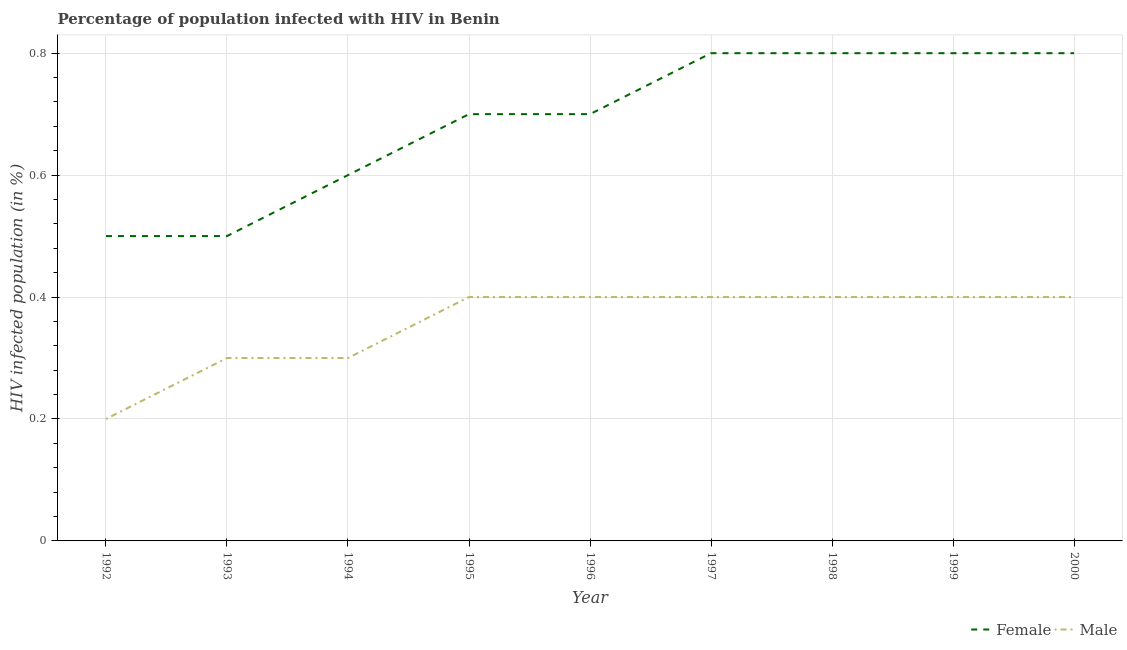Does the line corresponding to percentage of males who are infected with hiv intersect with the line corresponding to percentage of females who are infected with hiv?
Give a very brief answer. No. Is the number of lines equal to the number of legend labels?
Give a very brief answer. Yes. Across all years, what is the minimum percentage of females who are infected with hiv?
Your answer should be compact. 0.5. In which year was the percentage of males who are infected with hiv maximum?
Your answer should be compact. 1995. In which year was the percentage of females who are infected with hiv minimum?
Keep it short and to the point. 1992. What is the total percentage of females who are infected with hiv in the graph?
Your response must be concise. 6.2. What is the difference between the percentage of females who are infected with hiv in 1996 and that in 2000?
Your answer should be very brief. -0.1. What is the difference between the percentage of females who are infected with hiv in 1998 and the percentage of males who are infected with hiv in 2000?
Make the answer very short. 0.4. What is the average percentage of females who are infected with hiv per year?
Ensure brevity in your answer.  0.69. In how many years, is the percentage of males who are infected with hiv greater than 0.6400000000000001 %?
Your response must be concise. 0. What is the ratio of the percentage of females who are infected with hiv in 1993 to that in 1994?
Make the answer very short. 0.83. Is the percentage of females who are infected with hiv in 1997 less than that in 1998?
Give a very brief answer. No. What is the difference between the highest and the second highest percentage of females who are infected with hiv?
Provide a succinct answer. 0. What is the difference between the highest and the lowest percentage of females who are infected with hiv?
Your response must be concise. 0.3. Is the sum of the percentage of males who are infected with hiv in 1992 and 1994 greater than the maximum percentage of females who are infected with hiv across all years?
Your answer should be compact. No. Does the percentage of females who are infected with hiv monotonically increase over the years?
Offer a terse response. No. Is the percentage of females who are infected with hiv strictly less than the percentage of males who are infected with hiv over the years?
Offer a very short reply. No. How many years are there in the graph?
Offer a very short reply. 9. What is the difference between two consecutive major ticks on the Y-axis?
Make the answer very short. 0.2. Does the graph contain grids?
Your answer should be very brief. Yes. Where does the legend appear in the graph?
Your answer should be compact. Bottom right. How are the legend labels stacked?
Keep it short and to the point. Horizontal. What is the title of the graph?
Provide a short and direct response. Percentage of population infected with HIV in Benin. What is the label or title of the Y-axis?
Your answer should be compact. HIV infected population (in %). What is the HIV infected population (in %) in Male in 1992?
Your answer should be very brief. 0.2. What is the HIV infected population (in %) in Female in 1993?
Your answer should be very brief. 0.5. What is the HIV infected population (in %) of Male in 1993?
Keep it short and to the point. 0.3. What is the HIV infected population (in %) of Male in 1994?
Make the answer very short. 0.3. What is the HIV infected population (in %) in Female in 1996?
Keep it short and to the point. 0.7. What is the HIV infected population (in %) of Male in 1996?
Your response must be concise. 0.4. What is the HIV infected population (in %) of Male in 1997?
Provide a succinct answer. 0.4. What is the HIV infected population (in %) in Female in 1998?
Keep it short and to the point. 0.8. What is the HIV infected population (in %) in Male in 1998?
Your answer should be very brief. 0.4. What is the HIV infected population (in %) in Female in 1999?
Provide a succinct answer. 0.8. What is the HIV infected population (in %) of Female in 2000?
Your answer should be very brief. 0.8. Across all years, what is the maximum HIV infected population (in %) of Male?
Provide a short and direct response. 0.4. What is the total HIV infected population (in %) of Male in the graph?
Your answer should be compact. 3.2. What is the difference between the HIV infected population (in %) in Female in 1992 and that in 1993?
Your answer should be very brief. 0. What is the difference between the HIV infected population (in %) of Female in 1992 and that in 1994?
Provide a short and direct response. -0.1. What is the difference between the HIV infected population (in %) in Male in 1992 and that in 1994?
Offer a terse response. -0.1. What is the difference between the HIV infected population (in %) of Male in 1992 and that in 1995?
Offer a very short reply. -0.2. What is the difference between the HIV infected population (in %) of Female in 1992 and that in 1996?
Your answer should be very brief. -0.2. What is the difference between the HIV infected population (in %) in Female in 1992 and that in 1997?
Give a very brief answer. -0.3. What is the difference between the HIV infected population (in %) in Male in 1992 and that in 1997?
Ensure brevity in your answer.  -0.2. What is the difference between the HIV infected population (in %) in Female in 1992 and that in 1998?
Your response must be concise. -0.3. What is the difference between the HIV infected population (in %) of Female in 1992 and that in 1999?
Keep it short and to the point. -0.3. What is the difference between the HIV infected population (in %) of Male in 1992 and that in 1999?
Provide a short and direct response. -0.2. What is the difference between the HIV infected population (in %) of Male in 1992 and that in 2000?
Give a very brief answer. -0.2. What is the difference between the HIV infected population (in %) in Male in 1993 and that in 1994?
Provide a short and direct response. 0. What is the difference between the HIV infected population (in %) in Female in 1993 and that in 1995?
Give a very brief answer. -0.2. What is the difference between the HIV infected population (in %) of Male in 1993 and that in 1996?
Provide a short and direct response. -0.1. What is the difference between the HIV infected population (in %) in Female in 1993 and that in 1998?
Keep it short and to the point. -0.3. What is the difference between the HIV infected population (in %) of Male in 1993 and that in 1998?
Your response must be concise. -0.1. What is the difference between the HIV infected population (in %) in Female in 1993 and that in 2000?
Your response must be concise. -0.3. What is the difference between the HIV infected population (in %) in Male in 1993 and that in 2000?
Ensure brevity in your answer.  -0.1. What is the difference between the HIV infected population (in %) in Male in 1994 and that in 1995?
Offer a very short reply. -0.1. What is the difference between the HIV infected population (in %) of Female in 1994 and that in 1996?
Offer a terse response. -0.1. What is the difference between the HIV infected population (in %) of Female in 1994 and that in 1997?
Your response must be concise. -0.2. What is the difference between the HIV infected population (in %) of Female in 1994 and that in 1999?
Offer a very short reply. -0.2. What is the difference between the HIV infected population (in %) of Female in 1994 and that in 2000?
Ensure brevity in your answer.  -0.2. What is the difference between the HIV infected population (in %) of Female in 1995 and that in 1996?
Keep it short and to the point. 0. What is the difference between the HIV infected population (in %) of Female in 1995 and that in 1998?
Give a very brief answer. -0.1. What is the difference between the HIV infected population (in %) of Female in 1995 and that in 2000?
Your answer should be very brief. -0.1. What is the difference between the HIV infected population (in %) of Male in 1995 and that in 2000?
Give a very brief answer. 0. What is the difference between the HIV infected population (in %) of Female in 1996 and that in 1998?
Give a very brief answer. -0.1. What is the difference between the HIV infected population (in %) of Male in 1996 and that in 1998?
Give a very brief answer. 0. What is the difference between the HIV infected population (in %) of Male in 1996 and that in 1999?
Give a very brief answer. 0. What is the difference between the HIV infected population (in %) in Female in 1997 and that in 1998?
Ensure brevity in your answer.  0. What is the difference between the HIV infected population (in %) in Female in 1997 and that in 1999?
Offer a terse response. 0. What is the difference between the HIV infected population (in %) in Male in 1997 and that in 1999?
Offer a very short reply. 0. What is the difference between the HIV infected population (in %) of Female in 1997 and that in 2000?
Make the answer very short. 0. What is the difference between the HIV infected population (in %) of Male in 1997 and that in 2000?
Keep it short and to the point. 0. What is the difference between the HIV infected population (in %) in Female in 1998 and that in 1999?
Your response must be concise. 0. What is the difference between the HIV infected population (in %) in Male in 1998 and that in 1999?
Your response must be concise. 0. What is the difference between the HIV infected population (in %) of Female in 1999 and that in 2000?
Your answer should be very brief. 0. What is the difference between the HIV infected population (in %) in Female in 1992 and the HIV infected population (in %) in Male in 1995?
Your answer should be very brief. 0.1. What is the difference between the HIV infected population (in %) in Female in 1992 and the HIV infected population (in %) in Male in 1997?
Ensure brevity in your answer.  0.1. What is the difference between the HIV infected population (in %) in Female in 1992 and the HIV infected population (in %) in Male in 2000?
Keep it short and to the point. 0.1. What is the difference between the HIV infected population (in %) in Female in 1993 and the HIV infected population (in %) in Male in 1998?
Make the answer very short. 0.1. What is the difference between the HIV infected population (in %) of Female in 1993 and the HIV infected population (in %) of Male in 1999?
Offer a terse response. 0.1. What is the difference between the HIV infected population (in %) of Female in 1993 and the HIV infected population (in %) of Male in 2000?
Provide a succinct answer. 0.1. What is the difference between the HIV infected population (in %) of Female in 1994 and the HIV infected population (in %) of Male in 1995?
Give a very brief answer. 0.2. What is the difference between the HIV infected population (in %) of Female in 1994 and the HIV infected population (in %) of Male in 1996?
Your answer should be very brief. 0.2. What is the difference between the HIV infected population (in %) of Female in 1994 and the HIV infected population (in %) of Male in 1997?
Your answer should be very brief. 0.2. What is the difference between the HIV infected population (in %) in Female in 1994 and the HIV infected population (in %) in Male in 1998?
Give a very brief answer. 0.2. What is the difference between the HIV infected population (in %) in Female in 1995 and the HIV infected population (in %) in Male in 1997?
Provide a short and direct response. 0.3. What is the difference between the HIV infected population (in %) in Female in 1996 and the HIV infected population (in %) in Male in 1998?
Provide a short and direct response. 0.3. What is the difference between the HIV infected population (in %) in Female in 1996 and the HIV infected population (in %) in Male in 1999?
Provide a short and direct response. 0.3. What is the difference between the HIV infected population (in %) in Female in 1997 and the HIV infected population (in %) in Male in 1999?
Provide a succinct answer. 0.4. What is the difference between the HIV infected population (in %) in Female in 1998 and the HIV infected population (in %) in Male in 1999?
Give a very brief answer. 0.4. What is the difference between the HIV infected population (in %) in Female in 1999 and the HIV infected population (in %) in Male in 2000?
Your response must be concise. 0.4. What is the average HIV infected population (in %) of Female per year?
Your answer should be very brief. 0.69. What is the average HIV infected population (in %) of Male per year?
Your response must be concise. 0.36. In the year 1995, what is the difference between the HIV infected population (in %) of Female and HIV infected population (in %) of Male?
Your answer should be very brief. 0.3. In the year 1999, what is the difference between the HIV infected population (in %) of Female and HIV infected population (in %) of Male?
Offer a terse response. 0.4. In the year 2000, what is the difference between the HIV infected population (in %) of Female and HIV infected population (in %) of Male?
Make the answer very short. 0.4. What is the ratio of the HIV infected population (in %) in Female in 1992 to that in 1993?
Your answer should be compact. 1. What is the ratio of the HIV infected population (in %) in Male in 1992 to that in 1993?
Offer a very short reply. 0.67. What is the ratio of the HIV infected population (in %) in Female in 1992 to that in 1994?
Your answer should be very brief. 0.83. What is the ratio of the HIV infected population (in %) of Male in 1992 to that in 1994?
Offer a terse response. 0.67. What is the ratio of the HIV infected population (in %) in Female in 1992 to that in 1998?
Give a very brief answer. 0.62. What is the ratio of the HIV infected population (in %) of Male in 1992 to that in 1998?
Your response must be concise. 0.5. What is the ratio of the HIV infected population (in %) of Female in 1992 to that in 1999?
Keep it short and to the point. 0.62. What is the ratio of the HIV infected population (in %) of Female in 1992 to that in 2000?
Ensure brevity in your answer.  0.62. What is the ratio of the HIV infected population (in %) of Male in 1992 to that in 2000?
Provide a short and direct response. 0.5. What is the ratio of the HIV infected population (in %) of Male in 1993 to that in 1994?
Provide a short and direct response. 1. What is the ratio of the HIV infected population (in %) in Female in 1993 to that in 1995?
Offer a terse response. 0.71. What is the ratio of the HIV infected population (in %) in Female in 1993 to that in 1997?
Ensure brevity in your answer.  0.62. What is the ratio of the HIV infected population (in %) in Male in 1993 to that in 1998?
Ensure brevity in your answer.  0.75. What is the ratio of the HIV infected population (in %) of Female in 1993 to that in 1999?
Keep it short and to the point. 0.62. What is the ratio of the HIV infected population (in %) in Male in 1993 to that in 2000?
Provide a short and direct response. 0.75. What is the ratio of the HIV infected population (in %) in Female in 1994 to that in 1995?
Keep it short and to the point. 0.86. What is the ratio of the HIV infected population (in %) in Male in 1994 to that in 1996?
Give a very brief answer. 0.75. What is the ratio of the HIV infected population (in %) in Male in 1994 to that in 1998?
Offer a very short reply. 0.75. What is the ratio of the HIV infected population (in %) in Male in 1994 to that in 1999?
Ensure brevity in your answer.  0.75. What is the ratio of the HIV infected population (in %) of Female in 1994 to that in 2000?
Give a very brief answer. 0.75. What is the ratio of the HIV infected population (in %) in Male in 1994 to that in 2000?
Your answer should be compact. 0.75. What is the ratio of the HIV infected population (in %) of Male in 1995 to that in 1996?
Your answer should be very brief. 1. What is the ratio of the HIV infected population (in %) of Female in 1995 to that in 1997?
Keep it short and to the point. 0.88. What is the ratio of the HIV infected population (in %) of Male in 1995 to that in 1997?
Your answer should be very brief. 1. What is the ratio of the HIV infected population (in %) of Male in 1995 to that in 1998?
Your answer should be very brief. 1. What is the ratio of the HIV infected population (in %) of Female in 1995 to that in 1999?
Keep it short and to the point. 0.88. What is the ratio of the HIV infected population (in %) of Male in 1995 to that in 1999?
Your answer should be very brief. 1. What is the ratio of the HIV infected population (in %) of Female in 1995 to that in 2000?
Offer a terse response. 0.88. What is the ratio of the HIV infected population (in %) of Male in 1996 to that in 1998?
Your answer should be very brief. 1. What is the ratio of the HIV infected population (in %) in Female in 1996 to that in 1999?
Keep it short and to the point. 0.88. What is the ratio of the HIV infected population (in %) of Male in 1996 to that in 1999?
Your answer should be compact. 1. What is the ratio of the HIV infected population (in %) of Male in 1996 to that in 2000?
Your answer should be very brief. 1. What is the ratio of the HIV infected population (in %) of Female in 1997 to that in 1998?
Make the answer very short. 1. What is the ratio of the HIV infected population (in %) in Male in 1997 to that in 1998?
Your answer should be very brief. 1. What is the ratio of the HIV infected population (in %) of Female in 1997 to that in 1999?
Keep it short and to the point. 1. What is the ratio of the HIV infected population (in %) of Female in 1997 to that in 2000?
Your response must be concise. 1. What is the ratio of the HIV infected population (in %) in Male in 1997 to that in 2000?
Give a very brief answer. 1. What is the ratio of the HIV infected population (in %) in Female in 1998 to that in 1999?
Provide a short and direct response. 1. What is the ratio of the HIV infected population (in %) of Male in 1998 to that in 1999?
Provide a short and direct response. 1. What is the ratio of the HIV infected population (in %) in Female in 1998 to that in 2000?
Ensure brevity in your answer.  1. What is the ratio of the HIV infected population (in %) of Male in 1999 to that in 2000?
Your response must be concise. 1. What is the difference between the highest and the second highest HIV infected population (in %) of Female?
Keep it short and to the point. 0. What is the difference between the highest and the second highest HIV infected population (in %) of Male?
Offer a very short reply. 0. What is the difference between the highest and the lowest HIV infected population (in %) of Male?
Offer a terse response. 0.2. 